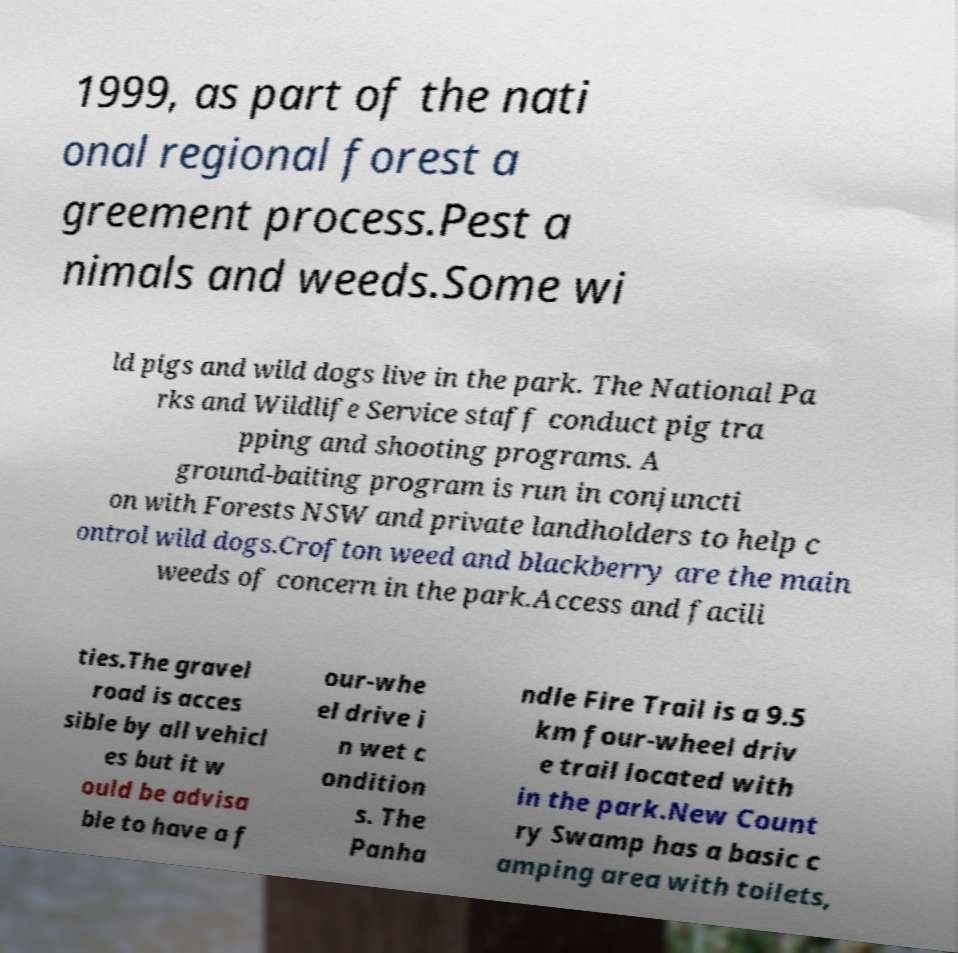Can you accurately transcribe the text from the provided image for me? 1999, as part of the nati onal regional forest a greement process.Pest a nimals and weeds.Some wi ld pigs and wild dogs live in the park. The National Pa rks and Wildlife Service staff conduct pig tra pping and shooting programs. A ground-baiting program is run in conjuncti on with Forests NSW and private landholders to help c ontrol wild dogs.Crofton weed and blackberry are the main weeds of concern in the park.Access and facili ties.The gravel road is acces sible by all vehicl es but it w ould be advisa ble to have a f our-whe el drive i n wet c ondition s. The Panha ndle Fire Trail is a 9.5 km four-wheel driv e trail located with in the park.New Count ry Swamp has a basic c amping area with toilets, 